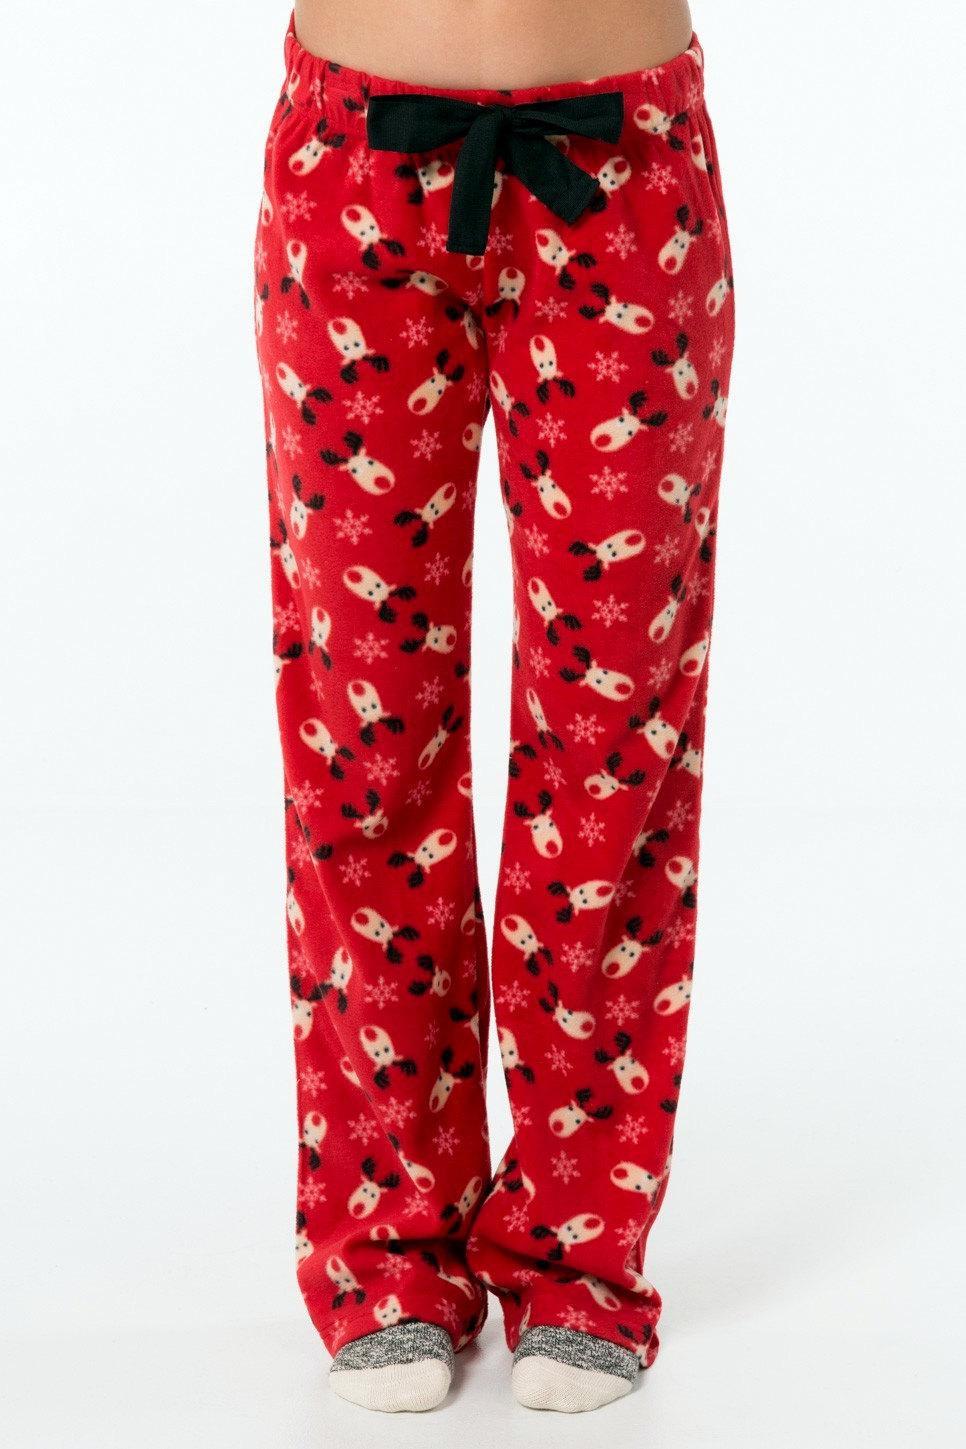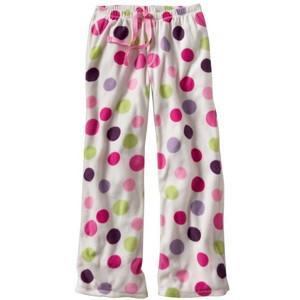The first image is the image on the left, the second image is the image on the right. Given the left and right images, does the statement "The image on the left shows part of a woman's stomach." hold true? Answer yes or no. Yes. 